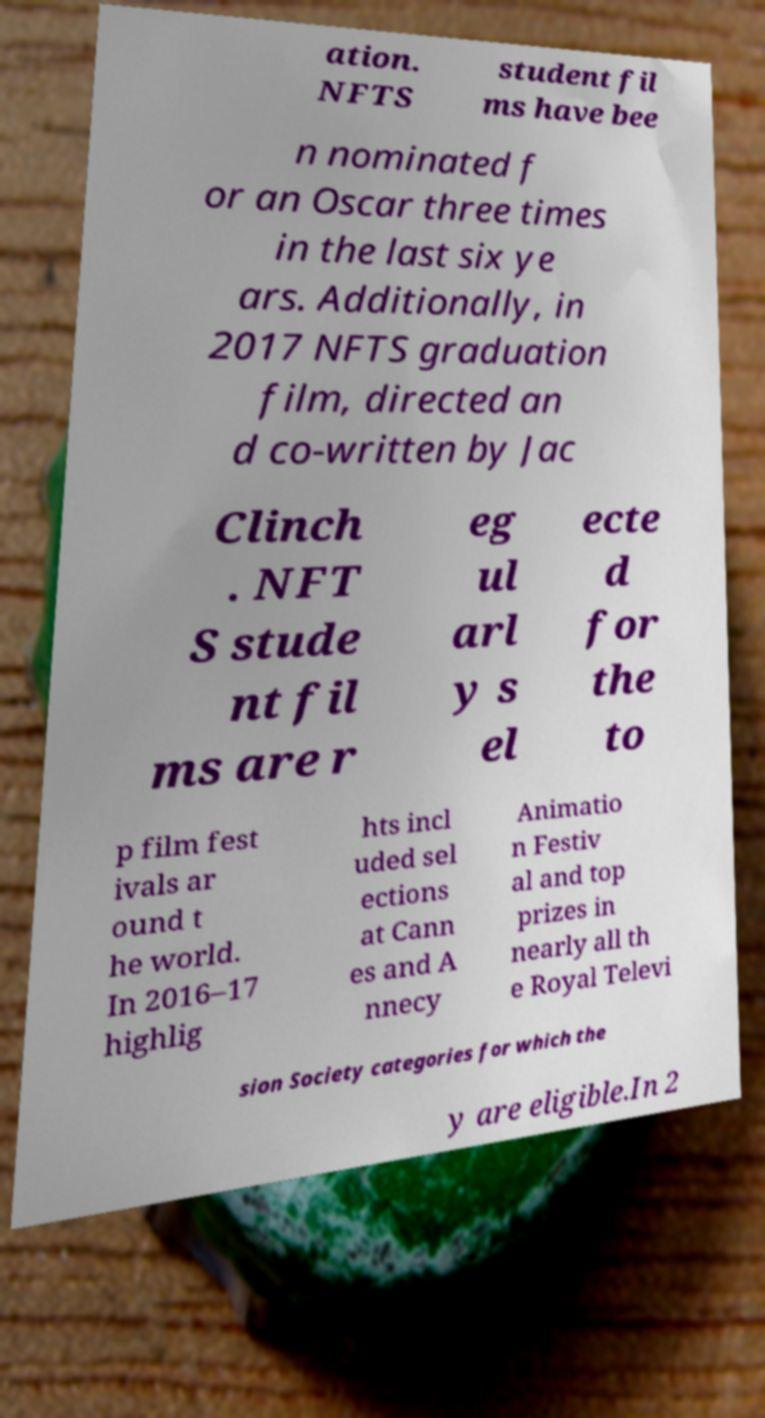Could you assist in decoding the text presented in this image and type it out clearly? ation. NFTS student fil ms have bee n nominated f or an Oscar three times in the last six ye ars. Additionally, in 2017 NFTS graduation film, directed an d co-written by Jac Clinch . NFT S stude nt fil ms are r eg ul arl y s el ecte d for the to p film fest ivals ar ound t he world. In 2016–17 highlig hts incl uded sel ections at Cann es and A nnecy Animatio n Festiv al and top prizes in nearly all th e Royal Televi sion Society categories for which the y are eligible.In 2 